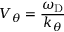Convert formula to latex. <formula><loc_0><loc_0><loc_500><loc_500>V _ { \theta } = \frac { \omega _ { D } } { k _ { \theta } }</formula> 